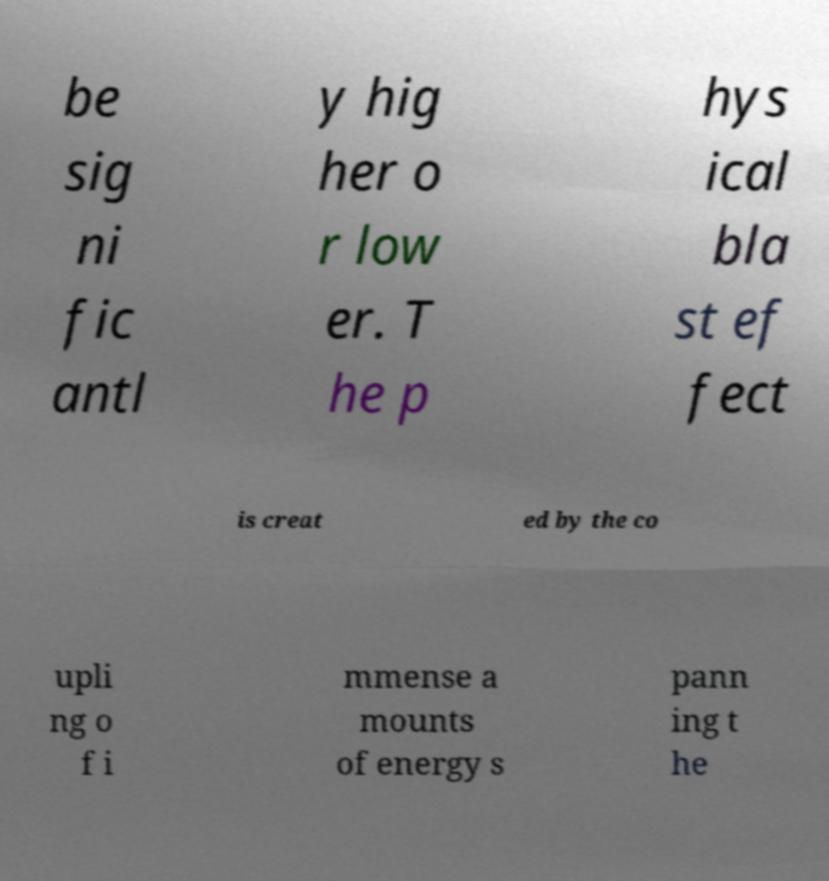Could you extract and type out the text from this image? be sig ni fic antl y hig her o r low er. T he p hys ical bla st ef fect is creat ed by the co upli ng o f i mmense a mounts of energy s pann ing t he 